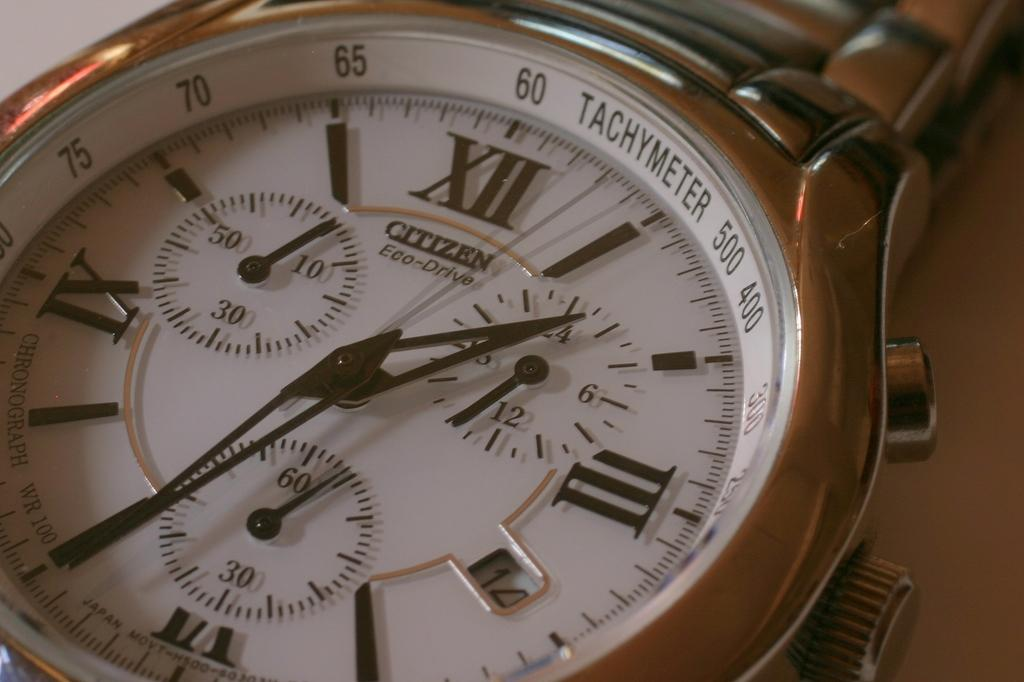<image>
Provide a brief description of the given image. A silver watch with Tachymeter written on the top. 